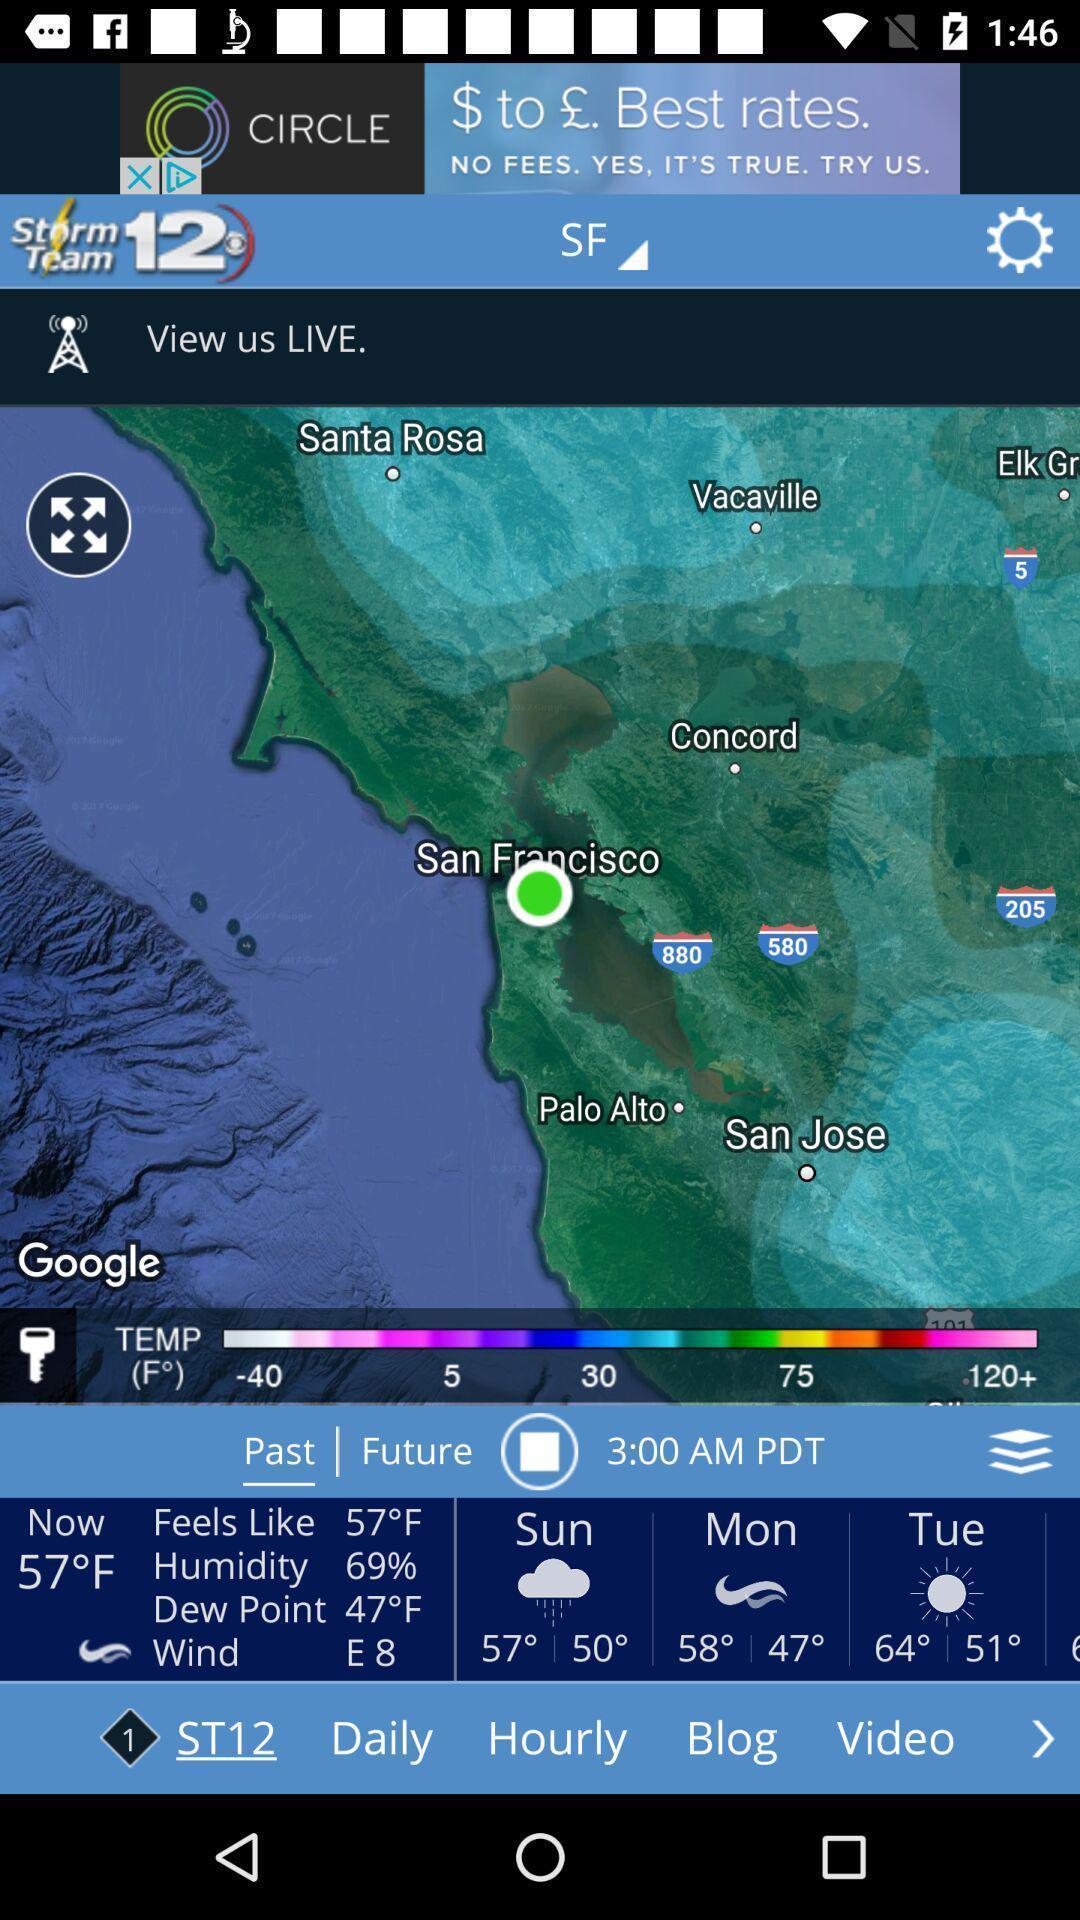Give me a summary of this screen capture. Window displaying a weather app. 